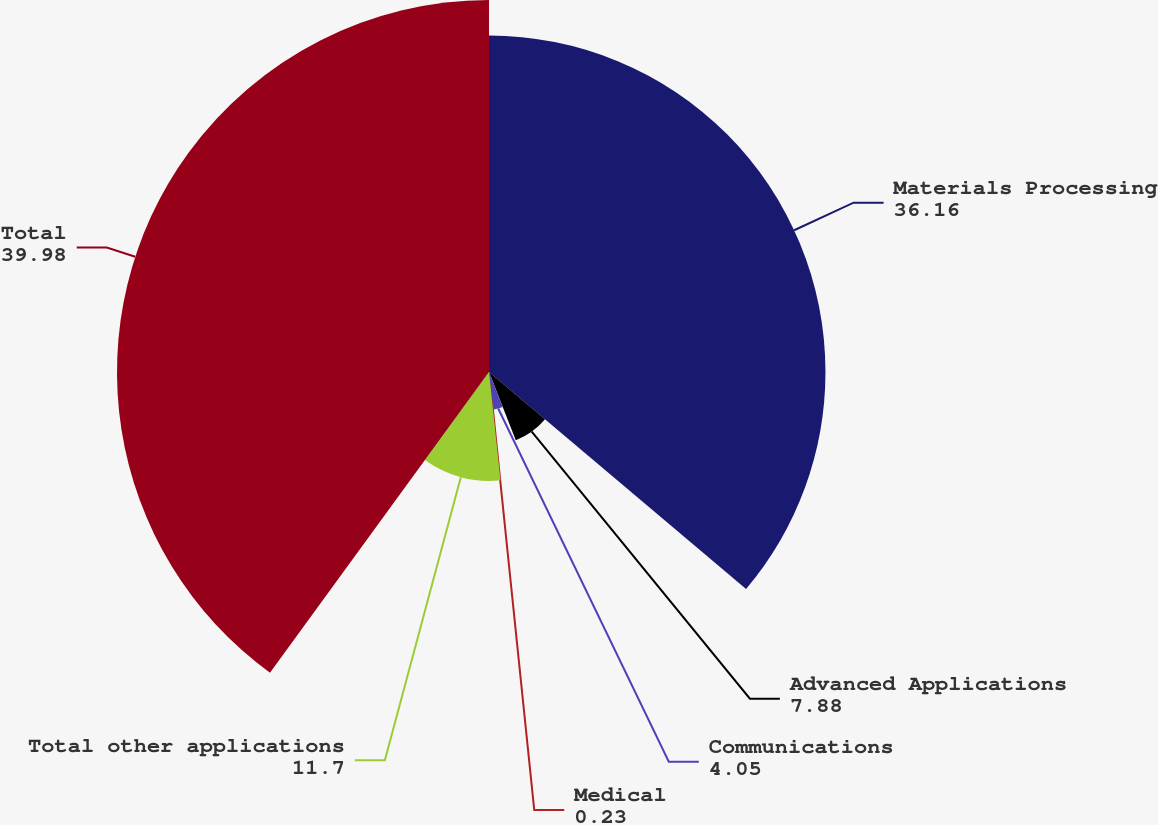Convert chart. <chart><loc_0><loc_0><loc_500><loc_500><pie_chart><fcel>Materials Processing<fcel>Advanced Applications<fcel>Communications<fcel>Medical<fcel>Total other applications<fcel>Total<nl><fcel>36.16%<fcel>7.88%<fcel>4.05%<fcel>0.23%<fcel>11.7%<fcel>39.98%<nl></chart> 